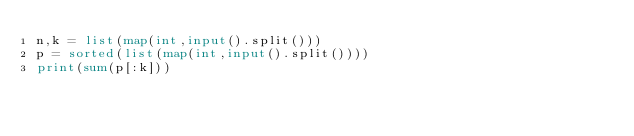<code> <loc_0><loc_0><loc_500><loc_500><_Python_>n,k = list(map(int,input().split()))
p = sorted(list(map(int,input().split())))
print(sum(p[:k]))</code> 